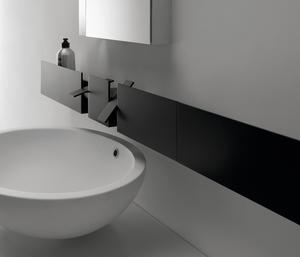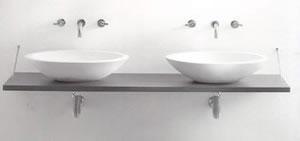The first image is the image on the left, the second image is the image on the right. Given the left and right images, does the statement "One image shows a wall-mounted rectangular counter with two separate sink and faucet features." hold true? Answer yes or no. Yes. The first image is the image on the left, the second image is the image on the right. Evaluate the accuracy of this statement regarding the images: "Every single sink has a basin in the shape of a bowl.". Is it true? Answer yes or no. Yes. The first image is the image on the left, the second image is the image on the right. Considering the images on both sides, is "There are two basins set in the counter on the right." valid? Answer yes or no. Yes. The first image is the image on the left, the second image is the image on the right. Given the left and right images, does the statement "In one image a sink and a bathroom floor are seen." hold true? Answer yes or no. No. 